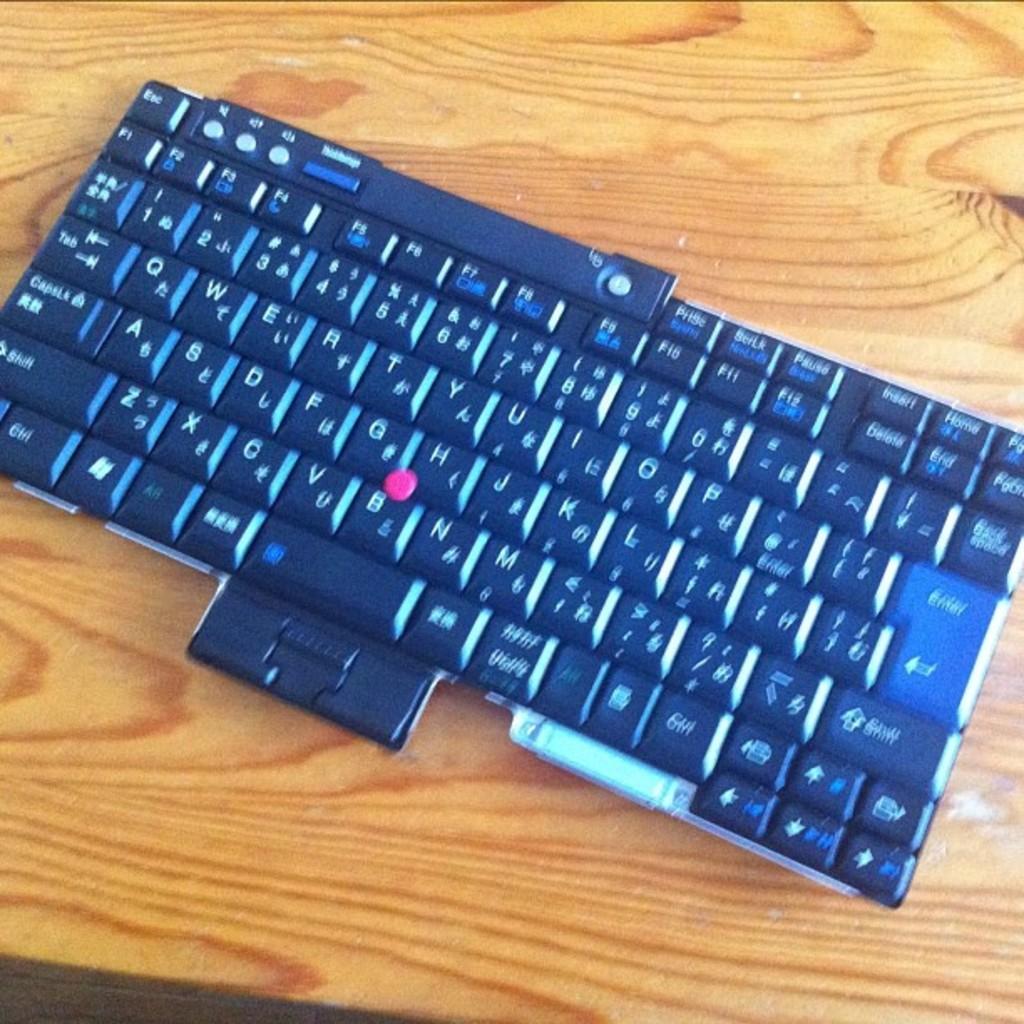What type of keyboard layout is this?
Your answer should be compact. Qwerty. What is one of the letters on the bottom row of the keyboard?
Offer a terse response. Z. 